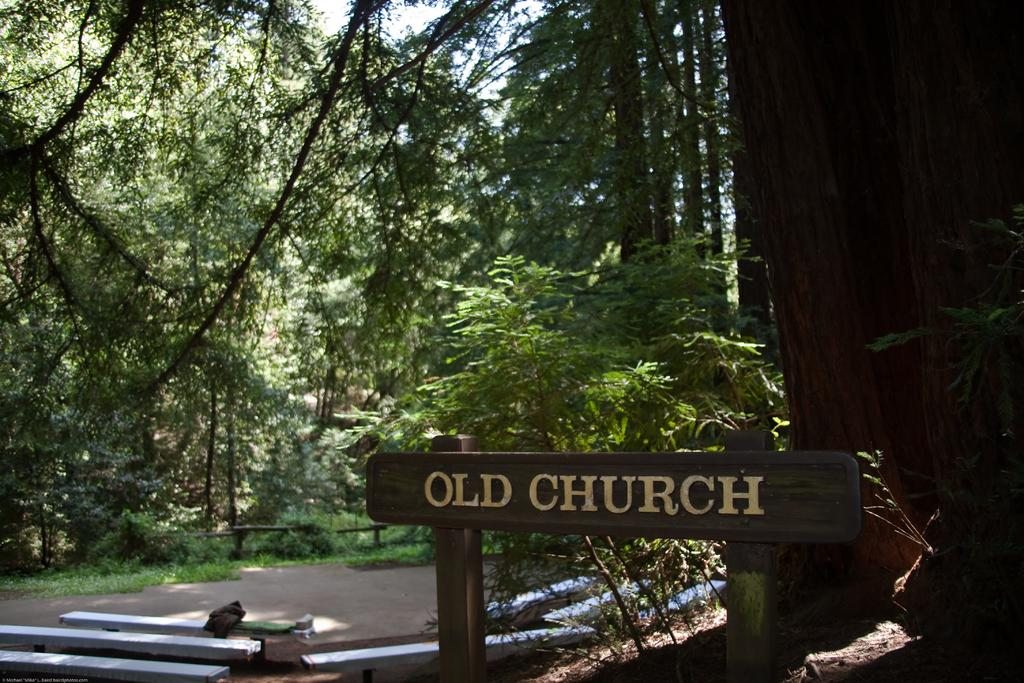What type of seating is visible in the image? There are benches in the image. What can be seen in the middle of the image? There are trees in the middle of the image. What is located at the bottom of the image? There is a board at the bottom of the image. How many sisters are sitting on the benches in the image? There is no mention of sisters in the image, and the number of people sitting on the benches is not specified. Is there an airplane flying above the trees in the image? There is no airplane visible in the image; only trees are mentioned. What language is written on the board at the bottom of the image? The language on the board is not specified in the image, so it cannot be determined. 